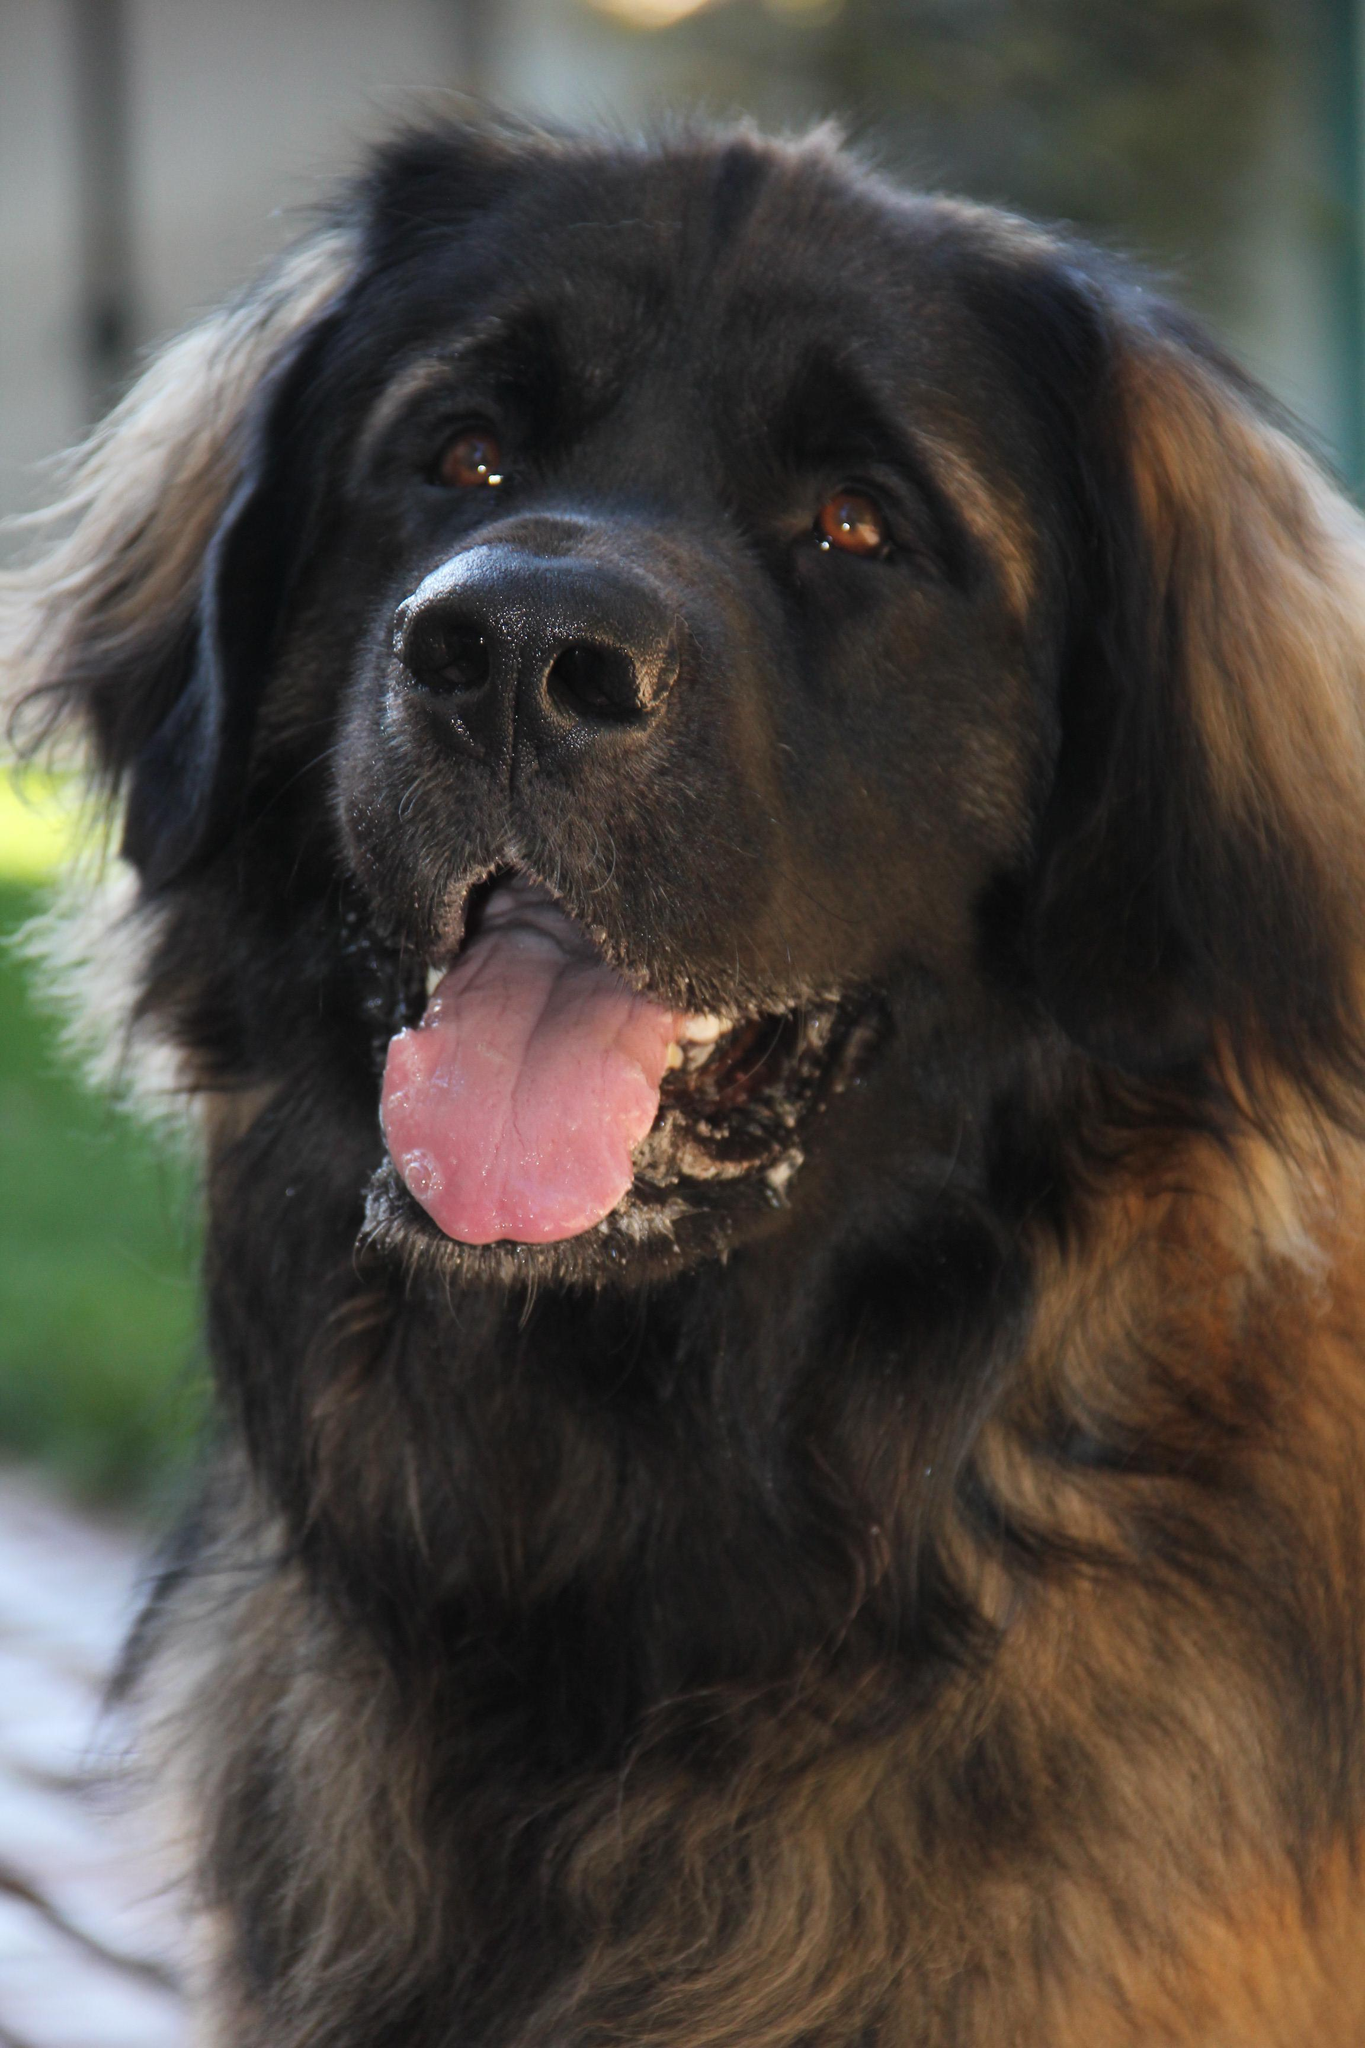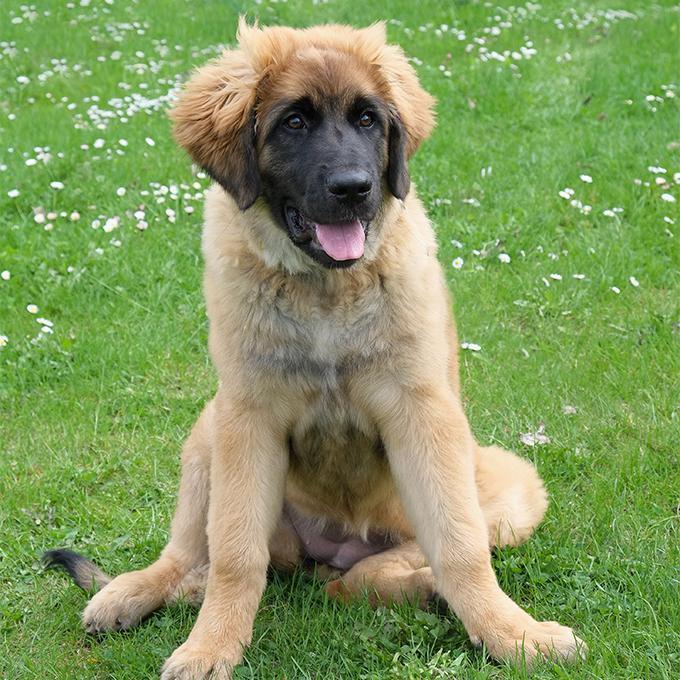The first image is the image on the left, the second image is the image on the right. Assess this claim about the two images: "There are three dogs.". Correct or not? Answer yes or no. No. 